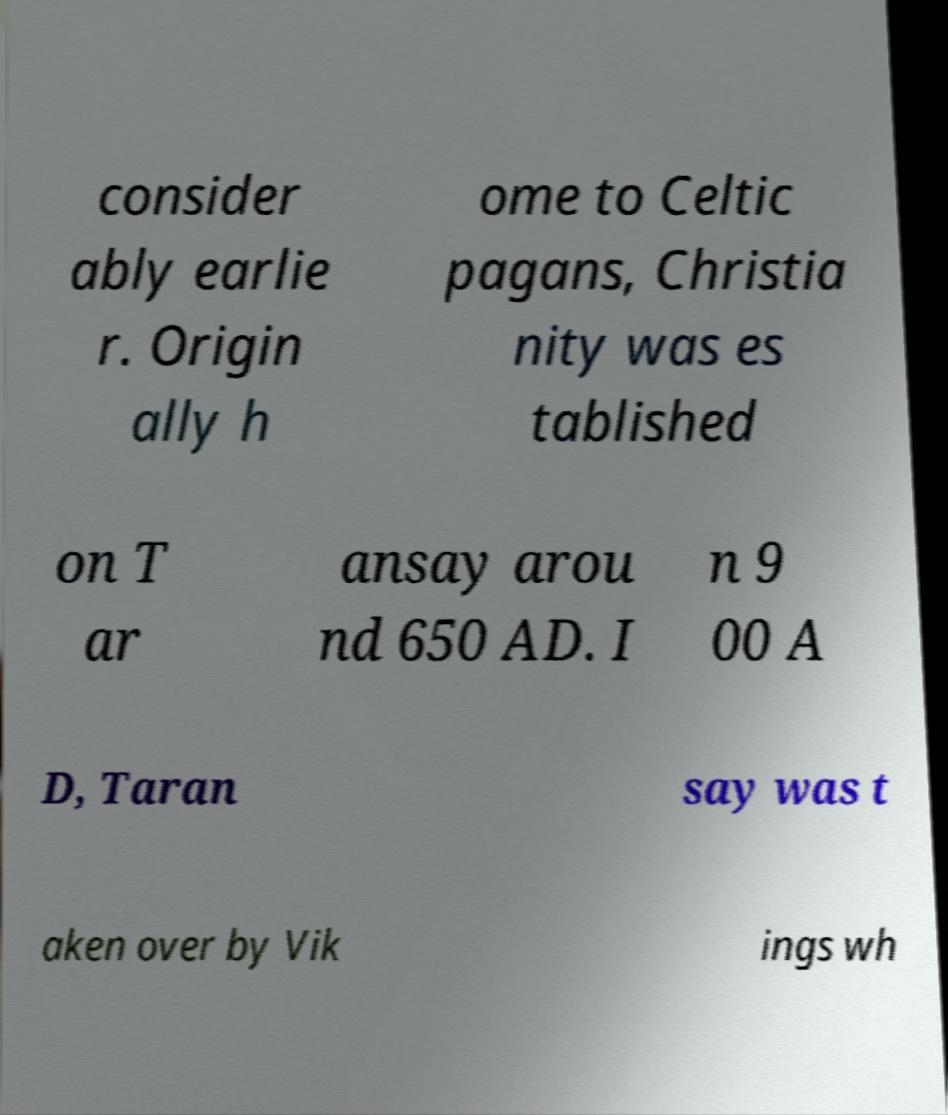Could you extract and type out the text from this image? consider ably earlie r. Origin ally h ome to Celtic pagans, Christia nity was es tablished on T ar ansay arou nd 650 AD. I n 9 00 A D, Taran say was t aken over by Vik ings wh 